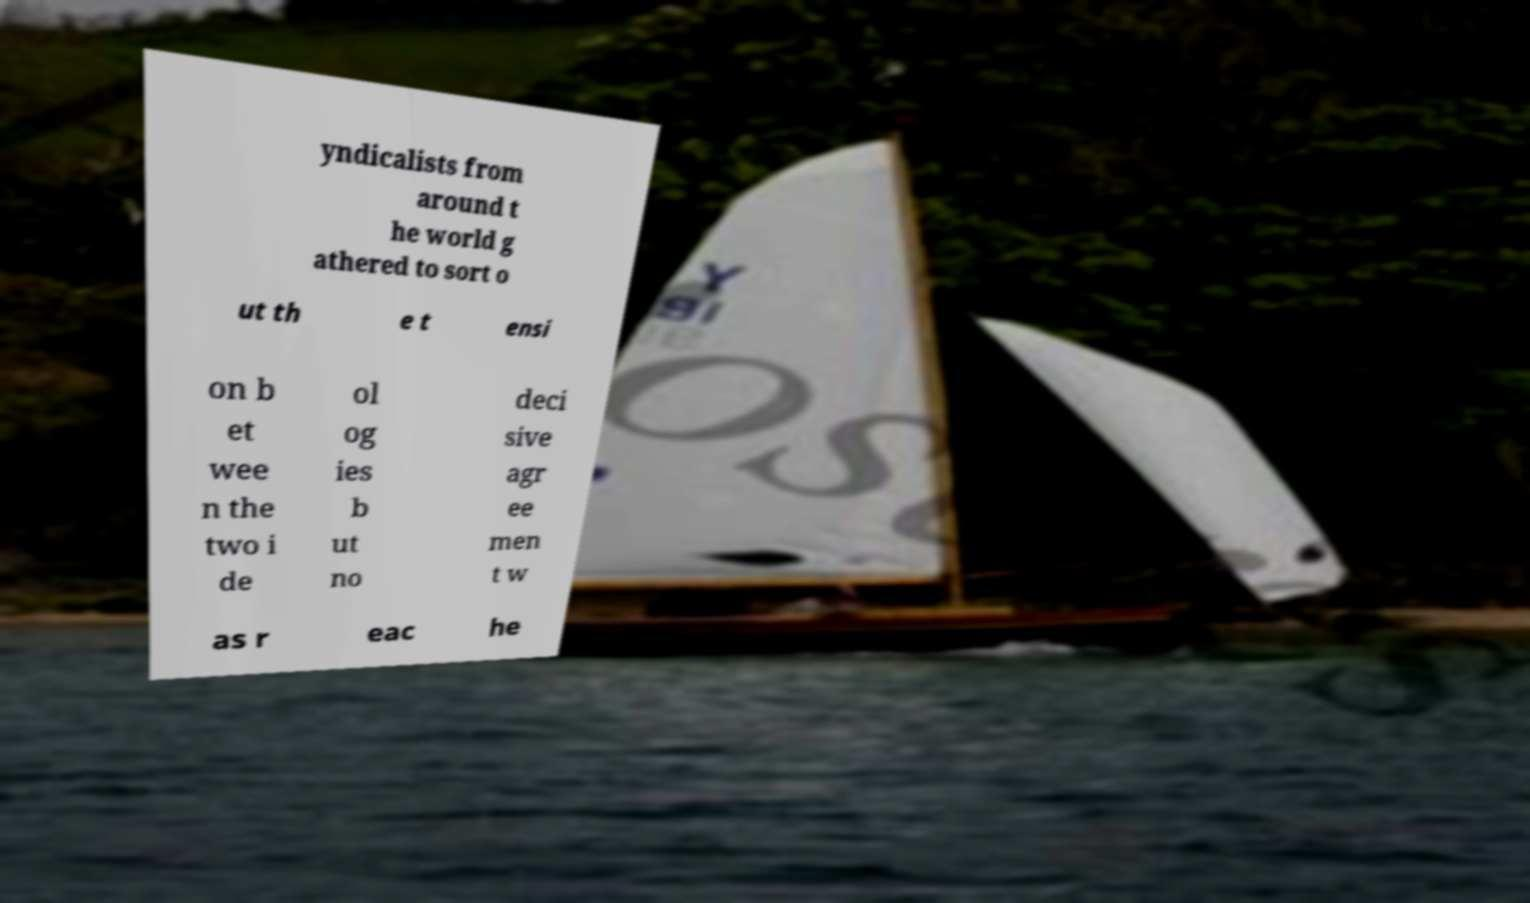I need the written content from this picture converted into text. Can you do that? yndicalists from around t he world g athered to sort o ut th e t ensi on b et wee n the two i de ol og ies b ut no deci sive agr ee men t w as r eac he 